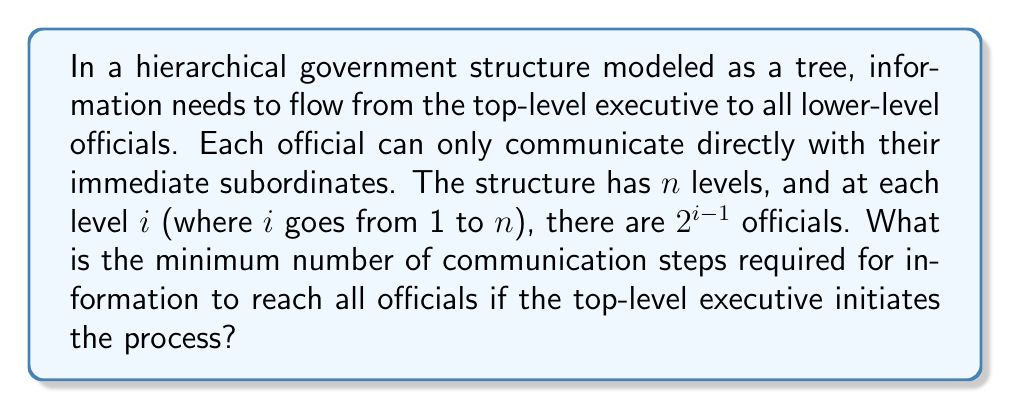Could you help me with this problem? To solve this problem, we need to understand the structure of the tree and how information flows through it. Let's approach this step-by-step:

1) First, let's visualize the structure:
   - Level 1 (top): $2^{1-1} = 1$ official (the executive)
   - Level 2: $2^{2-1} = 2$ officials
   - Level 3: $2^{3-1} = 4$ officials
   - ...
   - Level $n$: $2^{n-1}$ officials

2) In each step, an official can communicate with their immediate subordinates. This means that in one step, information can move down one level in the tree.

3) The minimum number of steps required will be equal to the number of levels minus one, as the information needs to traverse from the top level to the bottom level.

4) Therefore, the minimum number of communication steps is $n - 1$.

5) We can prove this mathematically:
   - Let $T(n)$ be the minimum number of steps for $n$ levels.
   - Base case: For $n = 1$, $T(1) = 0$ (no steps needed if there's only one level)
   - For $n > 1$, $T(n) = T(n-1) + 1$ (we need one more step than for $n-1$ levels)
   - Solving this recurrence: $T(n) = n - 1$

6) This solution is optimal because:
   a) Each level must receive the information sequentially
   b) No level can be skipped in the communication process

Therefore, $n - 1$ steps are both necessary and sufficient to reach all officials in the $n$-level structure.
Answer: The minimum number of communication steps required is $n - 1$, where $n$ is the number of levels in the hierarchical government structure. 